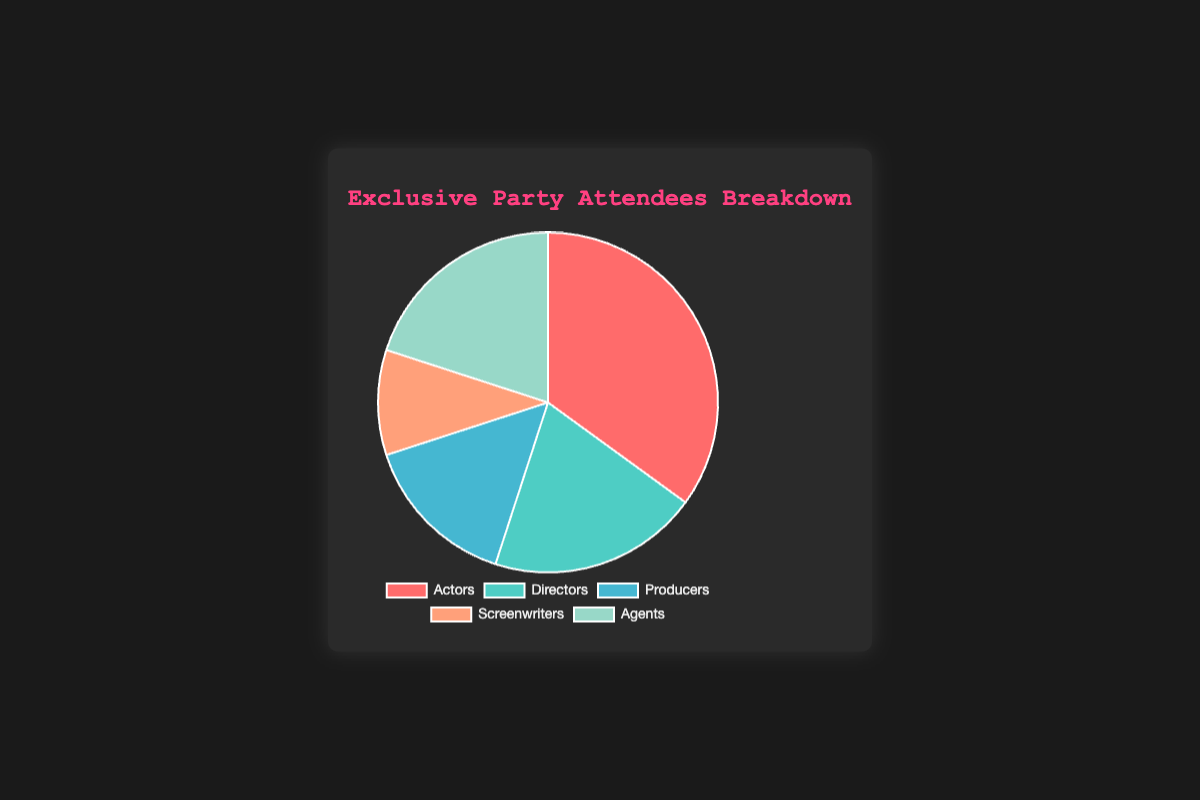What percentage of attendees are Agents? The pie chart shows the breakdown of attendees by profession. From the chart, Agents account for 20 attendees. To find the percentage, divide 20 by the total number of attendees (35 + 20 + 15 + 10 + 20 = 100) and multiply by 100. (20 / 100) * 100 = 20%.
Answer: 20% How many more Actors are there than Producers? Looking at the chart, there are 35 Actors and 15 Producers. The difference is calculated by subtracting the number of Producers from the number of Actors: 35 - 15 = 20.
Answer: 20 What is the combined total of Directors and Screenwriters? According to the chart, there are 20 Directors and 10 Screenwriters. Summing these numbers gives: 20 + 10 = 30.
Answer: 30 Which profession has the least number of attendees? By examining the chart, it's clear that Screenwriters have the smallest segment, indicating that they have the least number of attendees, which is 10.
Answer: Screenwriters What fraction of the attendees are Producers? The chart indicates that there are 15 Producers out of a total of 100 attendees. The fraction is thus 15/100, which simplifies to 3/20.
Answer: 3/20 Which group has more attendees, Agents or Directors? By comparing the chart sections, both Agents and Directors each have 20 attendees, so they are equal in number.
Answer: Equal What is the average number of attendees per profession? The total number of attendees is 100 and there are 5 professions. To find the average, divide the total number by 5: 100 / 5 = 20.
Answer: 20 Compare the percentage of Screenwriters to the percentage of Directors. The chart shows 10 Screenwriters and 20 Directors. To find the percentages, (10 / 100) * 100 = 10% for Screenwriters and (20 / 100) * 100 = 20% for Directors. Comparing these, we see that Directors make up 10% more of the attendees than Screenwriters.
Answer: Directors have 10% more If 5 more Producers attended the party, what would be their new total and share percentage? Currently, there are 15 Producers. Adding 5 more gives: 15 + 5 = 20. The new total becomes 105 attendees. The new percentage for Producers is: (20 / 105) * 100 ≈ 19%.
Answer: 20 producers, ≈ 19% What is the difference in attendees between the profession with the most attendees and the one with the fewest? The chart shows that Actors have the most attendees at 35, and Screenwriters have the fewest at 10. The difference is: 35 - 10 = 25.
Answer: 25 